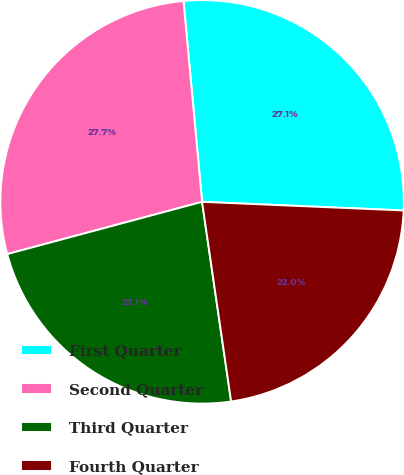Convert chart. <chart><loc_0><loc_0><loc_500><loc_500><pie_chart><fcel>First Quarter<fcel>Second Quarter<fcel>Third Quarter<fcel>Fourth Quarter<nl><fcel>27.15%<fcel>27.7%<fcel>23.13%<fcel>22.02%<nl></chart> 